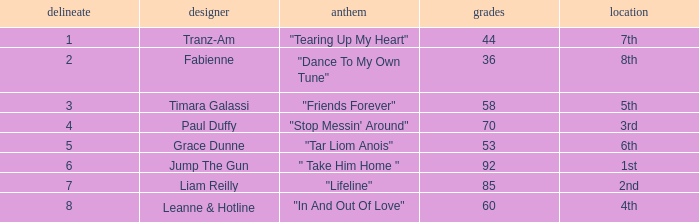What's the total number of points for grace dunne with a draw over 5? 0.0. 